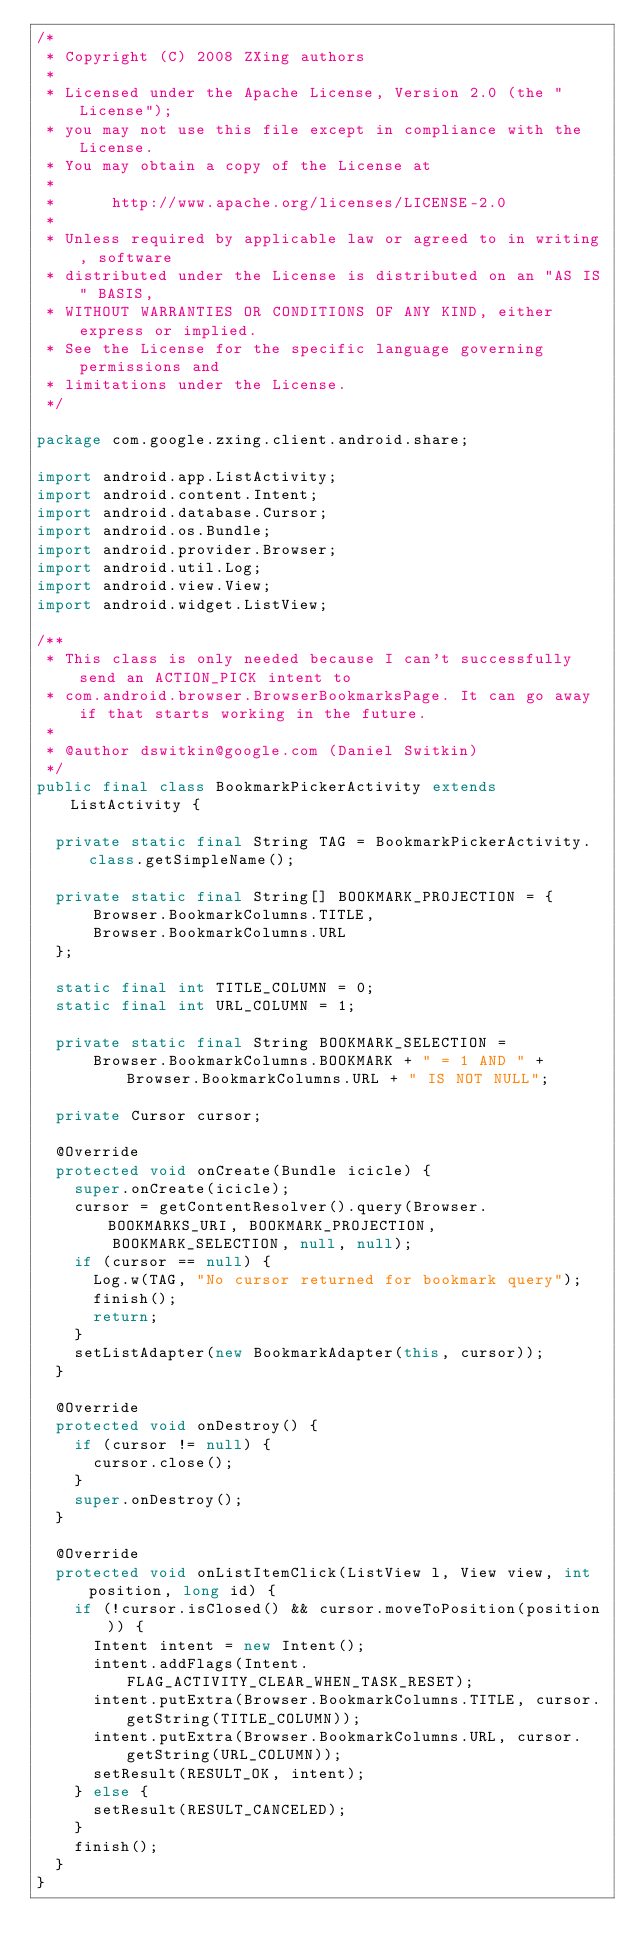<code> <loc_0><loc_0><loc_500><loc_500><_Java_>/*
 * Copyright (C) 2008 ZXing authors
 *
 * Licensed under the Apache License, Version 2.0 (the "License");
 * you may not use this file except in compliance with the License.
 * You may obtain a copy of the License at
 *
 *      http://www.apache.org/licenses/LICENSE-2.0
 *
 * Unless required by applicable law or agreed to in writing, software
 * distributed under the License is distributed on an "AS IS" BASIS,
 * WITHOUT WARRANTIES OR CONDITIONS OF ANY KIND, either express or implied.
 * See the License for the specific language governing permissions and
 * limitations under the License.
 */

package com.google.zxing.client.android.share;

import android.app.ListActivity;
import android.content.Intent;
import android.database.Cursor;
import android.os.Bundle;
import android.provider.Browser;
import android.util.Log;
import android.view.View;
import android.widget.ListView;

/**
 * This class is only needed because I can't successfully send an ACTION_PICK intent to
 * com.android.browser.BrowserBookmarksPage. It can go away if that starts working in the future.
 *
 * @author dswitkin@google.com (Daniel Switkin)
 */
public final class BookmarkPickerActivity extends ListActivity {

  private static final String TAG = BookmarkPickerActivity.class.getSimpleName();

  private static final String[] BOOKMARK_PROJECTION = {
      Browser.BookmarkColumns.TITLE,
      Browser.BookmarkColumns.URL
  };

  static final int TITLE_COLUMN = 0;
  static final int URL_COLUMN = 1;

  private static final String BOOKMARK_SELECTION = 
      Browser.BookmarkColumns.BOOKMARK + " = 1 AND " + Browser.BookmarkColumns.URL + " IS NOT NULL";

  private Cursor cursor;

  @Override
  protected void onCreate(Bundle icicle) {
    super.onCreate(icicle);
    cursor = getContentResolver().query(Browser.BOOKMARKS_URI, BOOKMARK_PROJECTION,
        BOOKMARK_SELECTION, null, null);
    if (cursor == null) {
      Log.w(TAG, "No cursor returned for bookmark query");
      finish();
      return;
    }
    setListAdapter(new BookmarkAdapter(this, cursor));
  }
  
  @Override
  protected void onDestroy() {
    if (cursor != null) {
      cursor.close();
    }
    super.onDestroy();
  }

  @Override
  protected void onListItemClick(ListView l, View view, int position, long id) {
    if (!cursor.isClosed() && cursor.moveToPosition(position)) {
      Intent intent = new Intent();
      intent.addFlags(Intent.FLAG_ACTIVITY_CLEAR_WHEN_TASK_RESET);
      intent.putExtra(Browser.BookmarkColumns.TITLE, cursor.getString(TITLE_COLUMN));
      intent.putExtra(Browser.BookmarkColumns.URL, cursor.getString(URL_COLUMN));
      setResult(RESULT_OK, intent);
    } else {
      setResult(RESULT_CANCELED);
    }
    finish();
  }
}
</code> 